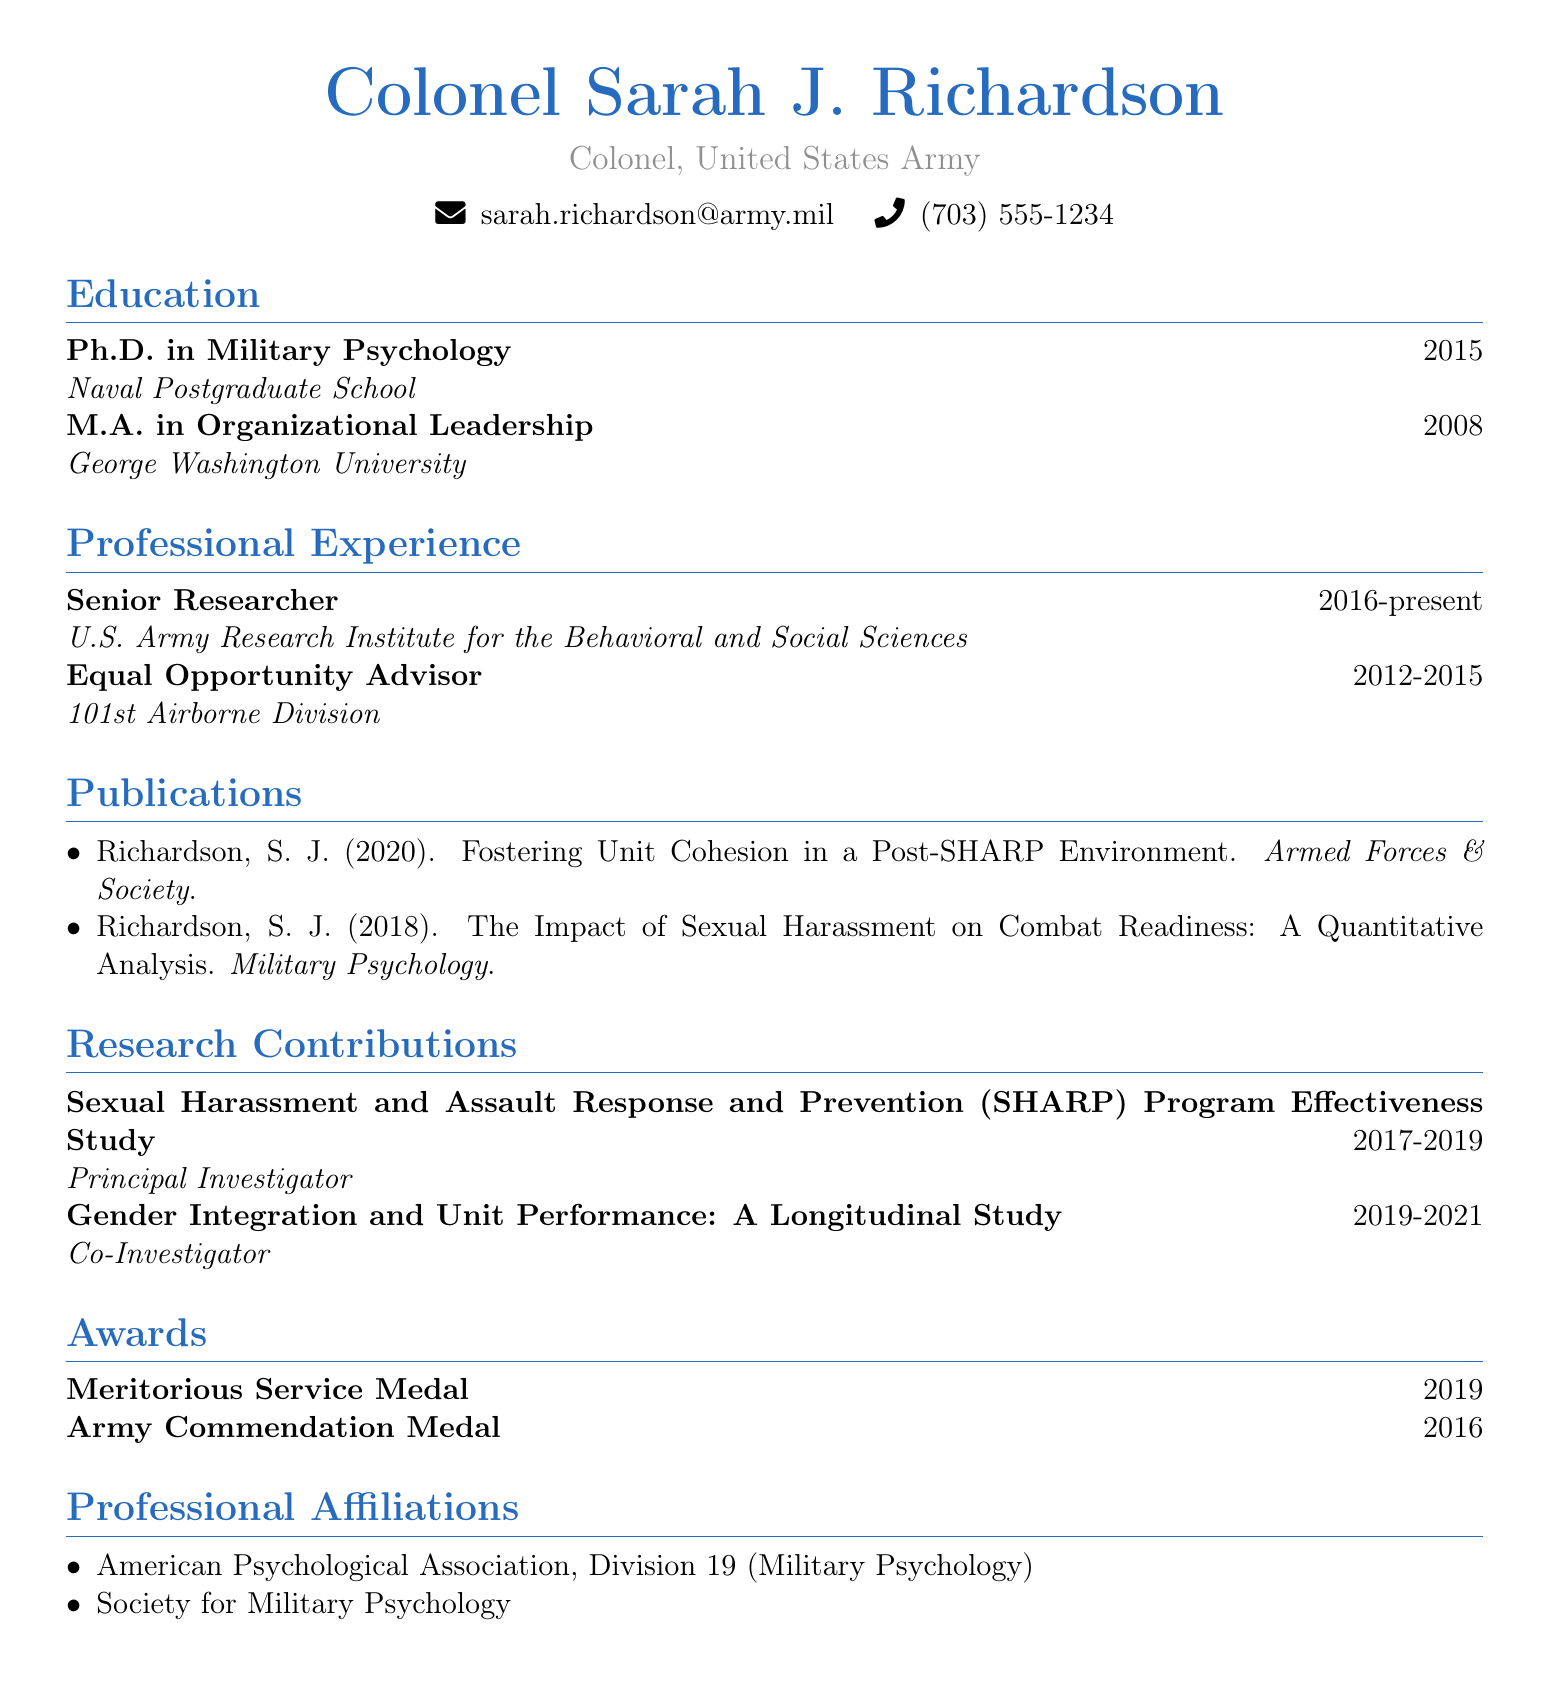What is the rank of Sarah J. Richardson? The rank of Sarah J. Richardson is listed at the beginning of the document.
Answer: Colonel, United States Army What year did Sarah complete her Ph.D.? The year of completion for Sarah's Ph.D. is detailed under the education section.
Answer: 2015 What is the title of the publication about sexual harassment and combat readiness? The title is found in the publications section specifically mentioning sexual harassment's impact.
Answer: The Impact of Sexual Harassment on Combat Readiness: A Quantitative Analysis Who was the Principal Investigator for the SHARP Program Effectiveness Study? The role and project are specified in the research contributions section of the document.
Answer: Sarah J. Richardson How many awards are listed in the curriculum vitae? The total count of awards is presented in the awards section of the document.
Answer: 2 What is the duration of Sarah's role as a Senior Researcher? The duration can be found in the professional experience section detailing her current position.
Answer: 2016-present In which journal was the publication "Fostering Unit Cohesion in a Post-SHARP Environment" published? The journal name is included in the publication citation.
Answer: Armed Forces & Society Which university did Sarah attend for her M.A.? The institution where Sarah completed her M.A. is mentioned in the education section.
Answer: George Washington University What is one of Sarah’s professional affiliations? The affiliations section lists professional organizations she is a member of.
Answer: American Psychological Association, Division 19 (Military Psychology) 